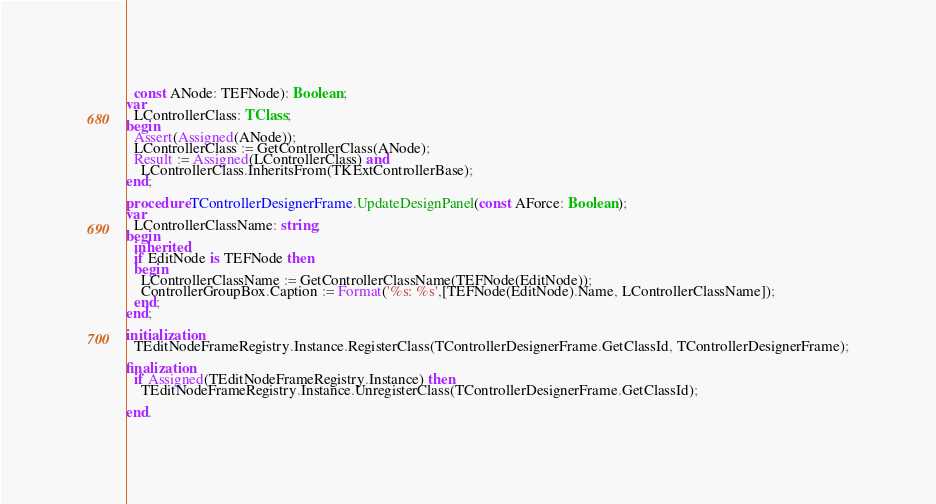Convert code to text. <code><loc_0><loc_0><loc_500><loc_500><_Pascal_>  const ANode: TEFNode): Boolean;
var
  LControllerClass: TClass;
begin
  Assert(Assigned(ANode));
  LControllerClass := GetControllerClass(ANode);
  Result := Assigned(LControllerClass) and
    LControllerClass.InheritsFrom(TKExtControllerBase);
end;

procedure TControllerDesignerFrame.UpdateDesignPanel(const AForce: Boolean);
var
  LControllerClassName: string;
begin
  inherited;
  if EditNode is TEFNode then
  begin
    LControllerClassName := GetControllerClassName(TEFNode(EditNode));
    ControllerGroupBox.Caption := Format('%s: %s',[TEFNode(EditNode).Name, LControllerClassName]);
  end;
end;

initialization
  TEditNodeFrameRegistry.Instance.RegisterClass(TControllerDesignerFrame.GetClassId, TControllerDesignerFrame);

finalization
  if Assigned(TEditNodeFrameRegistry.Instance) then
    TEditNodeFrameRegistry.Instance.UnregisterClass(TControllerDesignerFrame.GetClassId);

end.
</code> 